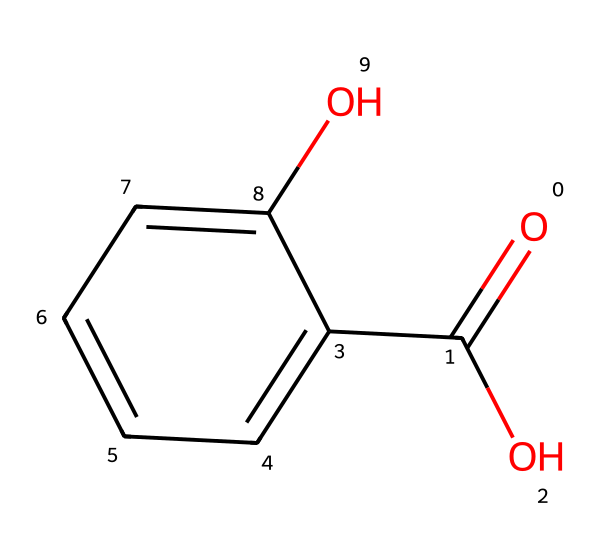What is the molecular formula of salicylic acid? The SMILES representation indicates the presence of a carboxylic acid group (COOH) and a phenolic hydroxyl group (OH) attached to a benzene ring. The carbons and hydrogens can be counted directly from the structure, leading to the conclusion that it has a molecular formula of C7H6O3.
Answer: C7H6O3 How many carbon atoms are in salicylic acid? By inspecting the SMILES structure, we can see that there are 7 carbon atoms which make up the aromatic ring and the carboxylic acid group.
Answer: 7 What functional groups are present in salicylic acid? The chemical has two main functional groups: a carboxylic acid (-COOH) and a hydroxyl group (-OH) attached to the aromatic ring, which are essential for its properties as an acne treatment.
Answer: carboxylic acid and hydroxyl What type of chemical reaction does salicylic acid undergo to be effective in treating acne? Salicylic acid works primarily through the process of exfoliation, which involves the shedding of dead skin cells. The presence of the hydroxyl group allows it to penetrate the pores and help dissolve excess oils, making it effective for acne treatment.
Answer: exfoliation Why does salicylic acid have anti-inflammatory properties? Salicylic acid's structure contains a hydroxyl group which is known to have anti-inflammatory effects. This group helps reduce redness and swelling associated with acne. The benzene ring also aids in its interaction with biological systems, enhancing its efficacy.
Answer: anti-inflammatory How does the presence of the hydroxyl group in salicylic acid affect its solubility? The hydroxyl group (-OH) is polar and can form hydrogen bonds with water, making salicylic acid more soluble in aqueous solutions. The polar nature of the hydroxyl group increases its interactions with water molecules, enhancing solubility compared to non-polar compounds.
Answer: increases solubility 